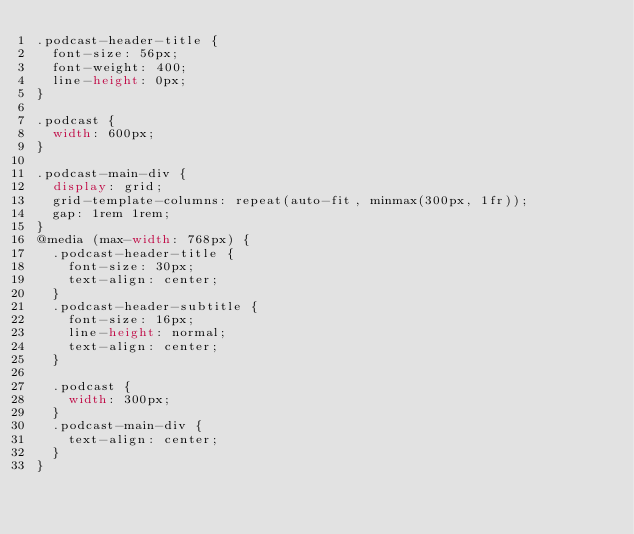<code> <loc_0><loc_0><loc_500><loc_500><_CSS_>.podcast-header-title {
  font-size: 56px;
  font-weight: 400;
  line-height: 0px;
}

.podcast {
  width: 600px;
}

.podcast-main-div {
  display: grid;
  grid-template-columns: repeat(auto-fit, minmax(300px, 1fr));
  gap: 1rem 1rem;
}
@media (max-width: 768px) {
  .podcast-header-title {
    font-size: 30px;
    text-align: center;
  }
  .podcast-header-subtitle {
    font-size: 16px;
    line-height: normal;
    text-align: center;
  }

  .podcast {
    width: 300px;
  }
  .podcast-main-div {
    text-align: center;
  }
}
</code> 